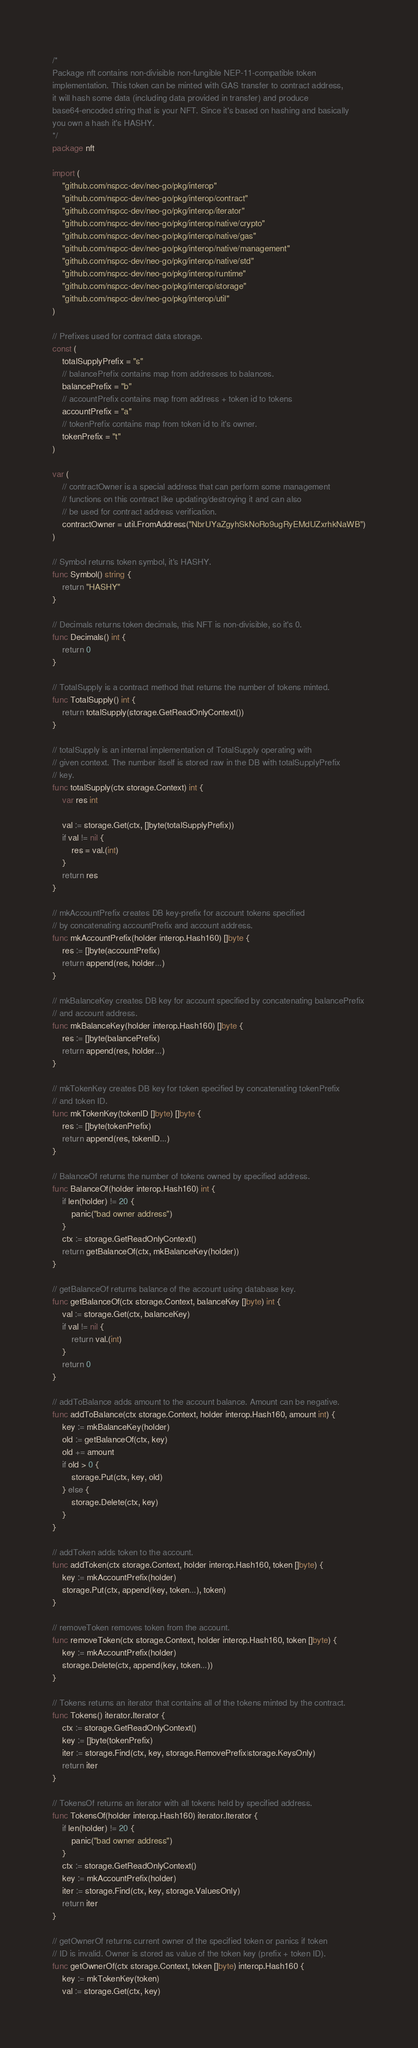Convert code to text. <code><loc_0><loc_0><loc_500><loc_500><_Go_>/*
Package nft contains non-divisible non-fungible NEP-11-compatible token
implementation. This token can be minted with GAS transfer to contract address,
it will hash some data (including data provided in transfer) and produce
base64-encoded string that is your NFT. Since it's based on hashing and basically
you own a hash it's HASHY.
*/
package nft

import (
	"github.com/nspcc-dev/neo-go/pkg/interop"
	"github.com/nspcc-dev/neo-go/pkg/interop/contract"
	"github.com/nspcc-dev/neo-go/pkg/interop/iterator"
	"github.com/nspcc-dev/neo-go/pkg/interop/native/crypto"
	"github.com/nspcc-dev/neo-go/pkg/interop/native/gas"
	"github.com/nspcc-dev/neo-go/pkg/interop/native/management"
	"github.com/nspcc-dev/neo-go/pkg/interop/native/std"
	"github.com/nspcc-dev/neo-go/pkg/interop/runtime"
	"github.com/nspcc-dev/neo-go/pkg/interop/storage"
	"github.com/nspcc-dev/neo-go/pkg/interop/util"
)

// Prefixes used for contract data storage.
const (
	totalSupplyPrefix = "s"
	// balancePrefix contains map from addresses to balances.
	balancePrefix = "b"
	// accountPrefix contains map from address + token id to tokens
	accountPrefix = "a"
	// tokenPrefix contains map from token id to it's owner.
	tokenPrefix = "t"
)

var (
	// contractOwner is a special address that can perform some management
	// functions on this contract like updating/destroying it and can also
	// be used for contract address verification.
	contractOwner = util.FromAddress("NbrUYaZgyhSkNoRo9ugRyEMdUZxrhkNaWB")
)

// Symbol returns token symbol, it's HASHY.
func Symbol() string {
	return "HASHY"
}

// Decimals returns token decimals, this NFT is non-divisible, so it's 0.
func Decimals() int {
	return 0
}

// TotalSupply is a contract method that returns the number of tokens minted.
func TotalSupply() int {
	return totalSupply(storage.GetReadOnlyContext())
}

// totalSupply is an internal implementation of TotalSupply operating with
// given context. The number itself is stored raw in the DB with totalSupplyPrefix
// key.
func totalSupply(ctx storage.Context) int {
	var res int

	val := storage.Get(ctx, []byte(totalSupplyPrefix))
	if val != nil {
		res = val.(int)
	}
	return res
}

// mkAccountPrefix creates DB key-prefix for account tokens specified
// by concatenating accountPrefix and account address.
func mkAccountPrefix(holder interop.Hash160) []byte {
	res := []byte(accountPrefix)
	return append(res, holder...)
}

// mkBalanceKey creates DB key for account specified by concatenating balancePrefix
// and account address.
func mkBalanceKey(holder interop.Hash160) []byte {
	res := []byte(balancePrefix)
	return append(res, holder...)
}

// mkTokenKey creates DB key for token specified by concatenating tokenPrefix
// and token ID.
func mkTokenKey(tokenID []byte) []byte {
	res := []byte(tokenPrefix)
	return append(res, tokenID...)
}

// BalanceOf returns the number of tokens owned by specified address.
func BalanceOf(holder interop.Hash160) int {
	if len(holder) != 20 {
		panic("bad owner address")
	}
	ctx := storage.GetReadOnlyContext()
	return getBalanceOf(ctx, mkBalanceKey(holder))
}

// getBalanceOf returns balance of the account using database key.
func getBalanceOf(ctx storage.Context, balanceKey []byte) int {
	val := storage.Get(ctx, balanceKey)
	if val != nil {
		return val.(int)
	}
	return 0
}

// addToBalance adds amount to the account balance. Amount can be negative.
func addToBalance(ctx storage.Context, holder interop.Hash160, amount int) {
	key := mkBalanceKey(holder)
	old := getBalanceOf(ctx, key)
	old += amount
	if old > 0 {
		storage.Put(ctx, key, old)
	} else {
		storage.Delete(ctx, key)
	}
}

// addToken adds token to the account.
func addToken(ctx storage.Context, holder interop.Hash160, token []byte) {
	key := mkAccountPrefix(holder)
	storage.Put(ctx, append(key, token...), token)
}

// removeToken removes token from the account.
func removeToken(ctx storage.Context, holder interop.Hash160, token []byte) {
	key := mkAccountPrefix(holder)
	storage.Delete(ctx, append(key, token...))
}

// Tokens returns an iterator that contains all of the tokens minted by the contract.
func Tokens() iterator.Iterator {
	ctx := storage.GetReadOnlyContext()
	key := []byte(tokenPrefix)
	iter := storage.Find(ctx, key, storage.RemovePrefix|storage.KeysOnly)
	return iter
}

// TokensOf returns an iterator with all tokens held by specified address.
func TokensOf(holder interop.Hash160) iterator.Iterator {
	if len(holder) != 20 {
		panic("bad owner address")
	}
	ctx := storage.GetReadOnlyContext()
	key := mkAccountPrefix(holder)
	iter := storage.Find(ctx, key, storage.ValuesOnly)
	return iter
}

// getOwnerOf returns current owner of the specified token or panics if token
// ID is invalid. Owner is stored as value of the token key (prefix + token ID).
func getOwnerOf(ctx storage.Context, token []byte) interop.Hash160 {
	key := mkTokenKey(token)
	val := storage.Get(ctx, key)</code> 